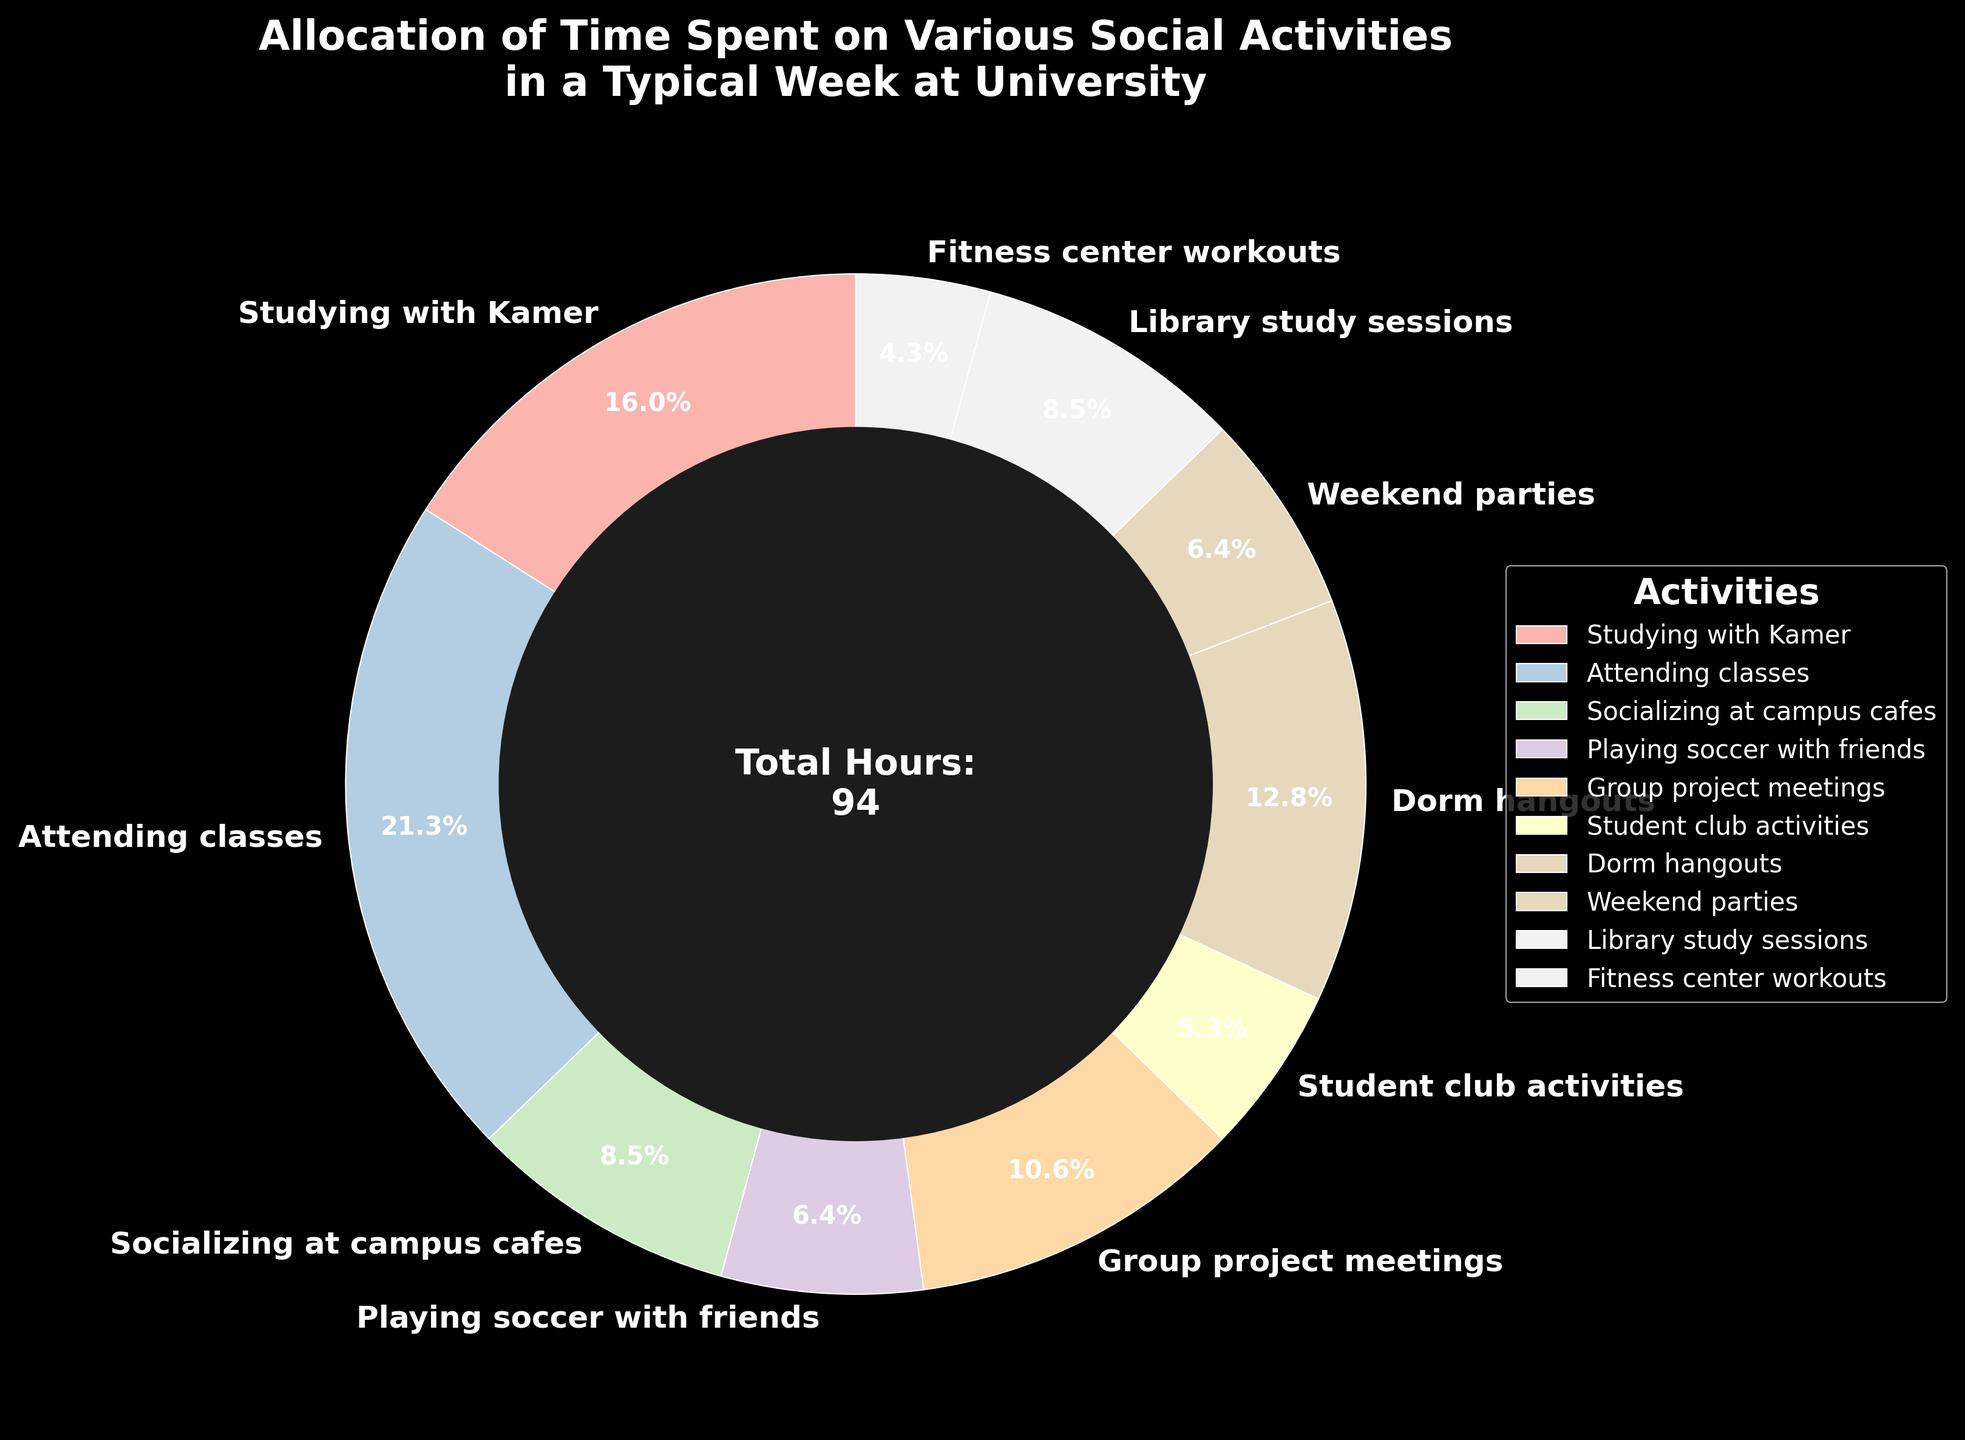What's the activity that takes up the largest percentage of time in a typical week? The largest wedge of the pie chart corresponds to "Attending classes" with the highest percentage.
Answer: Attending classes How many hours in total are spent on studying activities? Adding the hours spent studying with Kamer (15) and in library study sessions (8) gives the total hours for studying activities. 15 + 8 = 23.
Answer: 23 Which activity is allocated less time, weekend parties or playing soccer with friends? By comparing the segments labeled "Weekend parties" (6 hours) and "Playing soccer with friends" (6 hours), they both allocate equal time.
Answer: Equal time What is the total percentage of time spent on social activities excluding fitness center workouts? Sum the percentages for "Socializing at campus cafes" (8), "Playing soccer with friends" (6), "Group project meetings" (10), "Student club activities" (5), "Dorm hangouts" (12), "Weekend parties" (6) and "Library study sessions" (8). Total is 8 + 6 + 10 + 5 + 12 + 6 + 8 = 55 hours. Then, divide 55 by the total hours (94) and multiply by 100 to get the percentage. (55 / 94) * 100 ≈ 58.5%.
Answer: 58.5% What are the two activities that combine for the second largest percentage of time? After identifying the percentages, "Dorm hangouts" (12) and "Studying with Kamer" (15) together make 27 hours. This combined percentage is slightly less than that of “Attending classes.”
Answer: Dorm hangouts, Studying with Kamer How does the time spent on group project meetings compare to student club activities? "Group project meetings" takes up 10 hours, while "Student club activities" takes up 5 hours. Therefore, group project meetings use twice the amount of time.
Answer: Twice as much What colors are used for the activity that has the least amount of hours? The pie chart uses different colors for each activity. The activity "Fitness center workouts" (4 hours) is noted by a specific pastel color.
Answer: A specific pastel color Between "Dorm hangouts" and "Student club activities", which one occupies more time and by how much? "Dorm hangouts" (12 hours) and "Student club activities" (5 hours). Subtract the two amounts: 12 - 5 = 7.
Answer: Dorm hangouts by 7 hours If we combine "Weekend parties" and "Playing soccer with friends", what percentage of the total time does that make up? Adding the hours for "Weekend parties" (6) and "Playing soccer with friends" (6) gives 12 hours. To find the percentage: (12 / 94) * 100 ≈ 12.8%.
Answer: 12.8% What's the average number of hours spent on each activity? Total hours are 94 distributed across 10 activities. Thus, the average is 94 / 10 = 9.4 hours per activity.
Answer: 9.4 hours per activity 